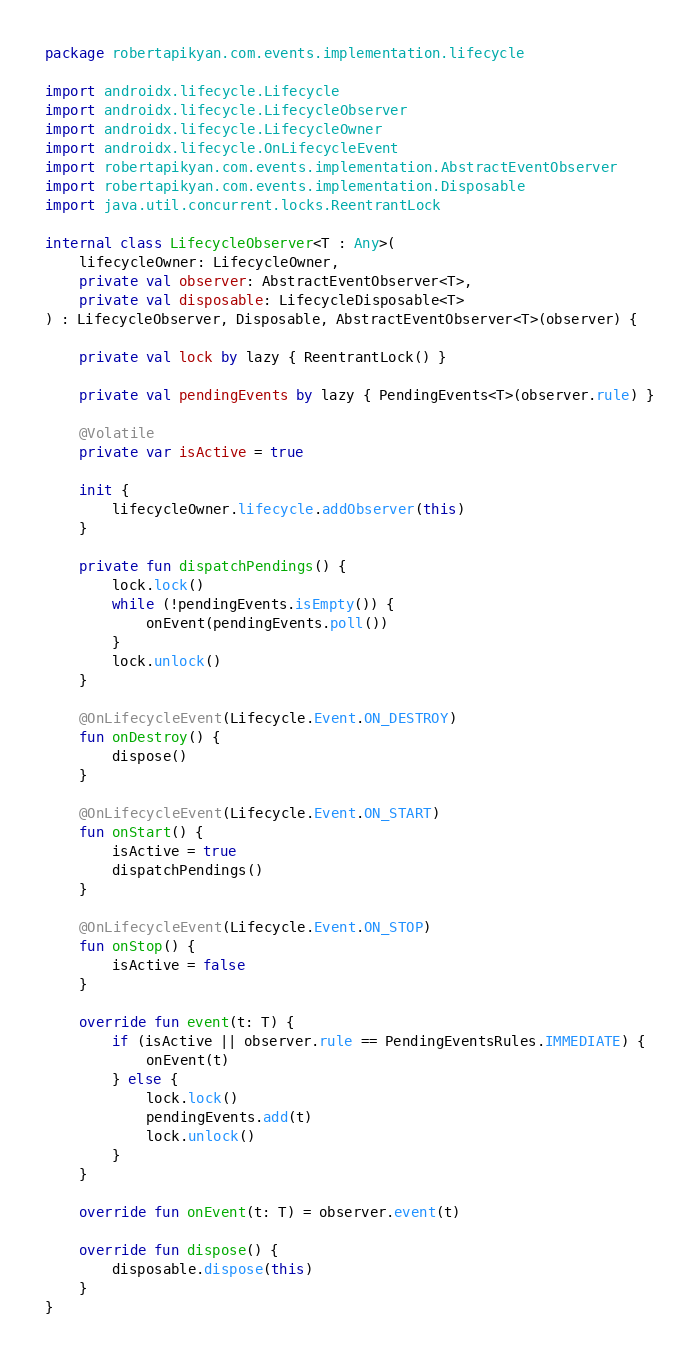<code> <loc_0><loc_0><loc_500><loc_500><_Kotlin_>package robertapikyan.com.events.implementation.lifecycle

import androidx.lifecycle.Lifecycle
import androidx.lifecycle.LifecycleObserver
import androidx.lifecycle.LifecycleOwner
import androidx.lifecycle.OnLifecycleEvent
import robertapikyan.com.events.implementation.AbstractEventObserver
import robertapikyan.com.events.implementation.Disposable
import java.util.concurrent.locks.ReentrantLock

internal class LifecycleObserver<T : Any>(
    lifecycleOwner: LifecycleOwner,
    private val observer: AbstractEventObserver<T>,
    private val disposable: LifecycleDisposable<T>
) : LifecycleObserver, Disposable, AbstractEventObserver<T>(observer) {

    private val lock by lazy { ReentrantLock() }

    private val pendingEvents by lazy { PendingEvents<T>(observer.rule) }

    @Volatile
    private var isActive = true

    init {
        lifecycleOwner.lifecycle.addObserver(this)
    }

    private fun dispatchPendings() {
        lock.lock()
        while (!pendingEvents.isEmpty()) {
            onEvent(pendingEvents.poll())
        }
        lock.unlock()
    }

    @OnLifecycleEvent(Lifecycle.Event.ON_DESTROY)
    fun onDestroy() {
        dispose()
    }

    @OnLifecycleEvent(Lifecycle.Event.ON_START)
    fun onStart() {
        isActive = true
        dispatchPendings()
    }

    @OnLifecycleEvent(Lifecycle.Event.ON_STOP)
    fun onStop() {
        isActive = false
    }

    override fun event(t: T) {
        if (isActive || observer.rule == PendingEventsRules.IMMEDIATE) {
            onEvent(t)
        } else {
            lock.lock()
            pendingEvents.add(t)
            lock.unlock()
        }
    }

    override fun onEvent(t: T) = observer.event(t)

    override fun dispose() {
        disposable.dispose(this)
    }
}</code> 